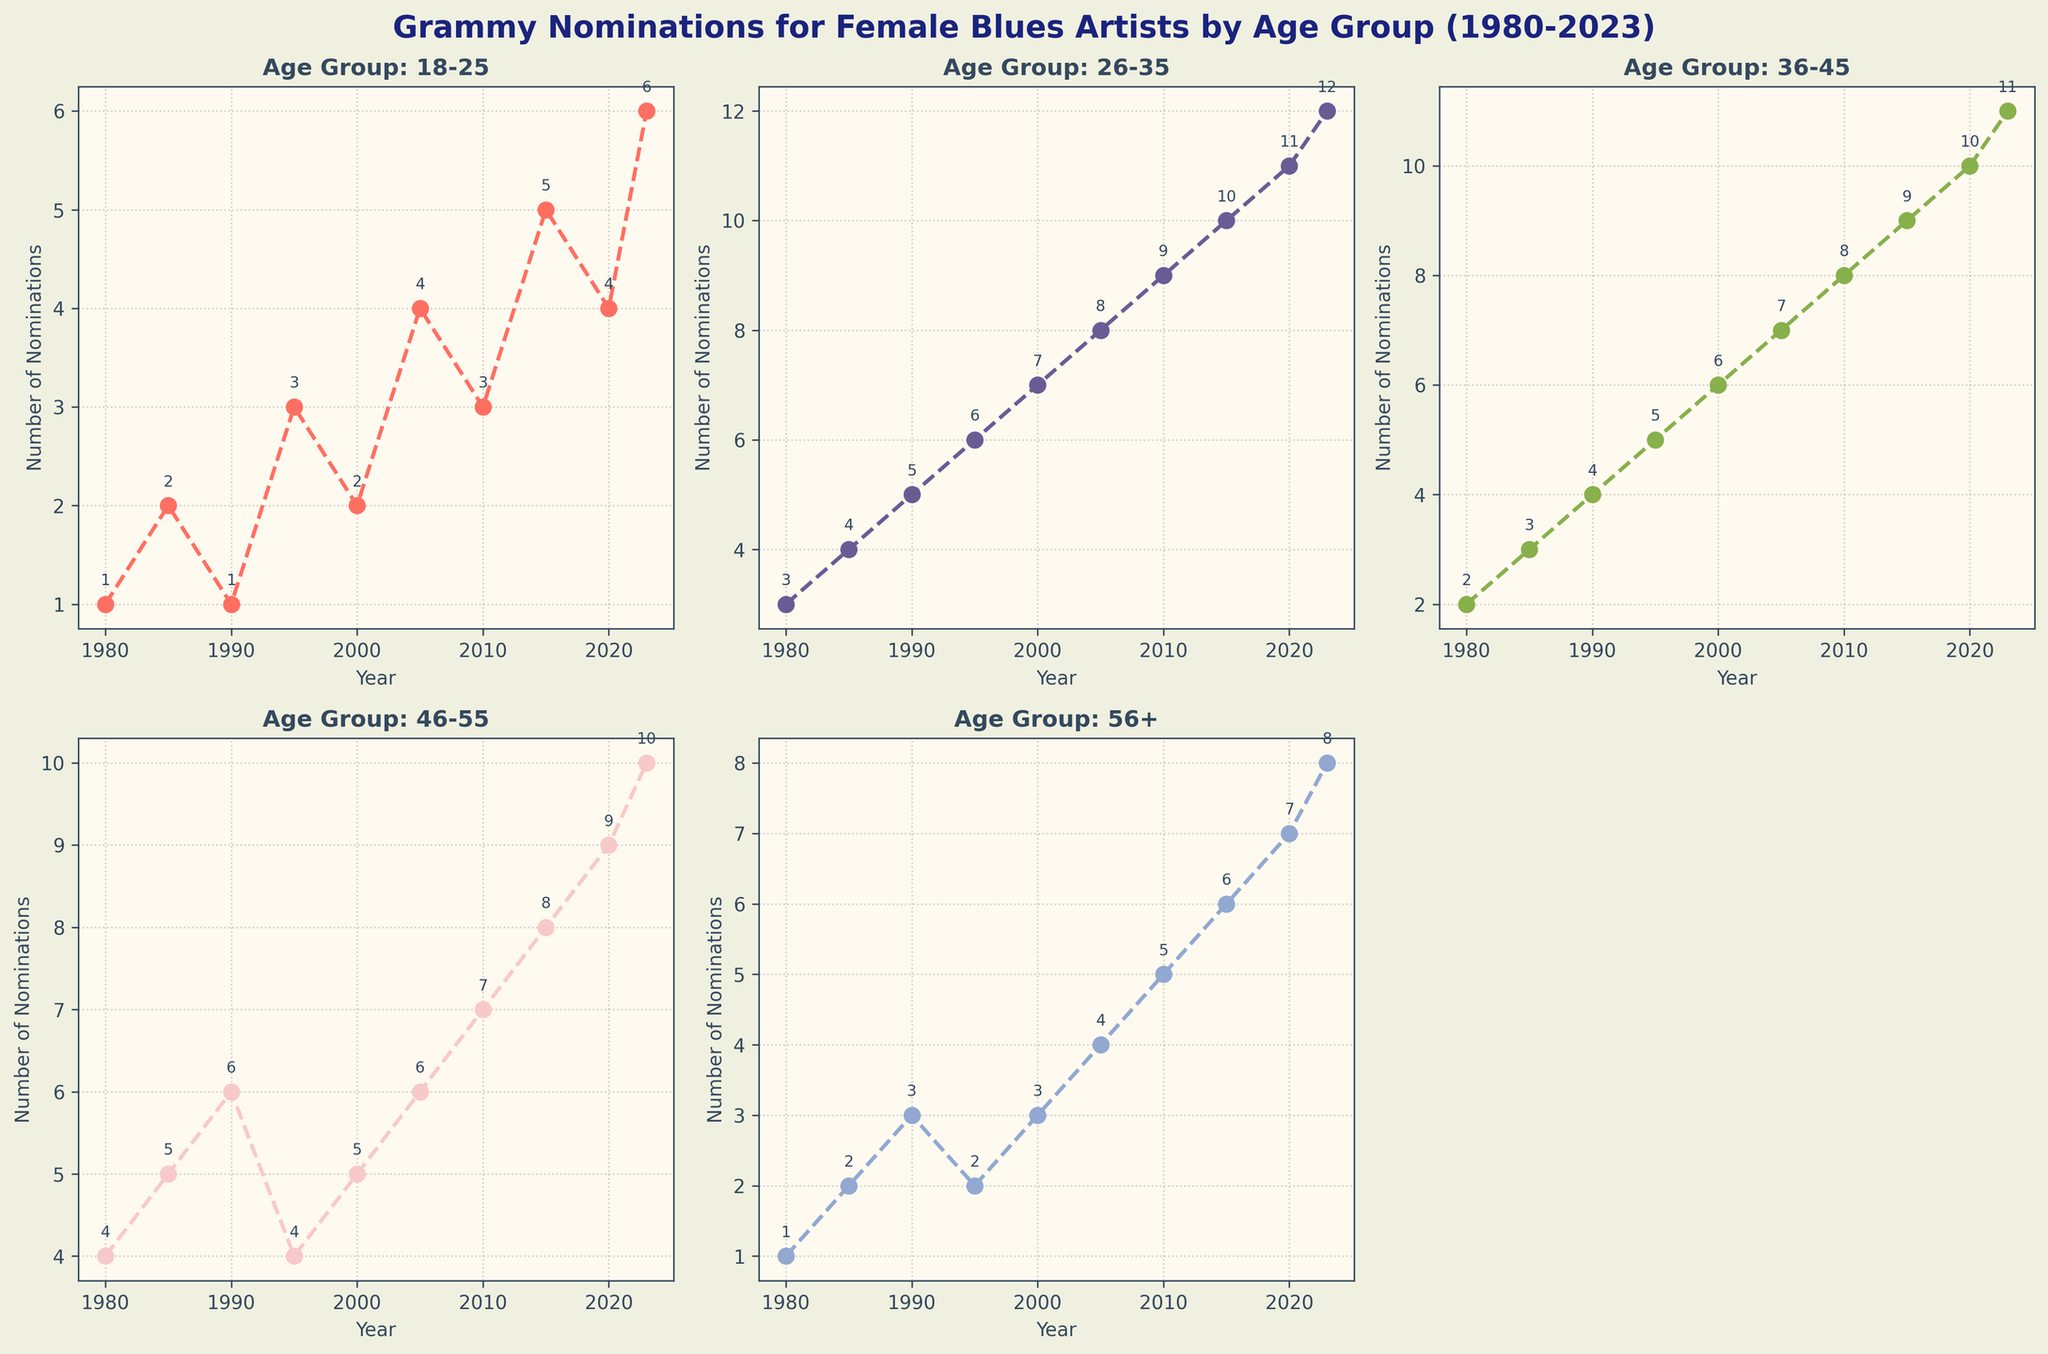what is the title of the figure? The title is typically placed at the top of the figure and it summarizes the content of the plot. In this case, it reads "Grammy Nominations for Female Blues Artists by Age Group (1980-2023)".
Answer: Grammy Nominations for Female Blues Artists by Age Group (1980-2023) how many age groups are displayed in the figure? The figure shows line charts for each age group, and you can count the number of small separate plots, which are five.
Answer: 5 which year showed the highest number of Grammy nominations for the 56+ age group? Referring to the subplot for the 56+ age group, the line peaks at the year 2023 with 8 nominations.
Answer: 2023 what was the continuous increase in Grammy nominations for the 26-35 age group from 1980 to 2023? By checking all the plotted data points for the 26-35 age group from 1980 to 2023, it shows a continuous line going upward without any dips. By following this trend, it increases from 3 in 1980 to 12 in 2023 without any decrease.
Answer: Yes which age group had the highest number of Grammy nominations in the year 2005? Looking at the 2005 data across all subplots, the highest number of Grammy nominations was in the 26-35 age group with 8 nominations.
Answer: 26-35 how many total Grammy nominations were there for the 18-25 age group from 1980 to 2023? Sum up the nominations for the 18-25 age group across all years: 1 (1980) + 2 (1985) + 1 (1990) + 3 (1995) + 2 (2000) + 4 (2005) + 3 (2010) + 5 (2015) + 4 (2020) + 6 (2023).
Answer: 31 in which year did the 46-55 age group surpass the 36-45 age group for the first time? On the line charts for 46-55 and 36-45 age groups, we see the 46-55 age line surpasses the 36-45 age line for the first time in 1980, with 4 nominations compared to 2 nominations.
Answer: 1980 which age group experienced the biggest increase from 2010 to 2013? Looking at each subplot, the 18-25 age group made the biggest increase from 3 nominations in 2010 to 5 in 2015.
Answer: 18-25 what is the overall trend for the 18-25 age group nominations from 1980 to 2023? Visually following the line for the 18-25 age group across the years, we can see it fluctuates, but overall, it shows an upward trend.
Answer: Increasing which age group consistently had the lowest number of Grammy nominations in the 1990s? By evaluating each subplot, it can be seen the 18-25 age group had the lowest number of nominations consistently in the 1990s.
Answer: 18-25 